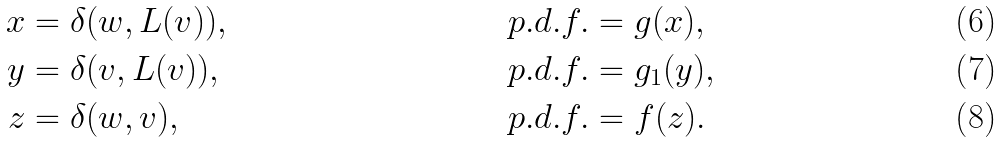Convert formula to latex. <formula><loc_0><loc_0><loc_500><loc_500>x & = \delta ( w , L ( v ) ) , & p . d . f . & = g ( x ) , \\ y & = \delta ( v , L ( v ) ) , & p . d . f . & = g _ { 1 } ( y ) , \\ z & = \delta ( w , v ) , & p . d . f . & = f ( z ) .</formula> 